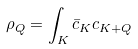<formula> <loc_0><loc_0><loc_500><loc_500>\rho _ { Q } = \int _ { K } \bar { c } _ { K } c _ { K + Q }</formula> 